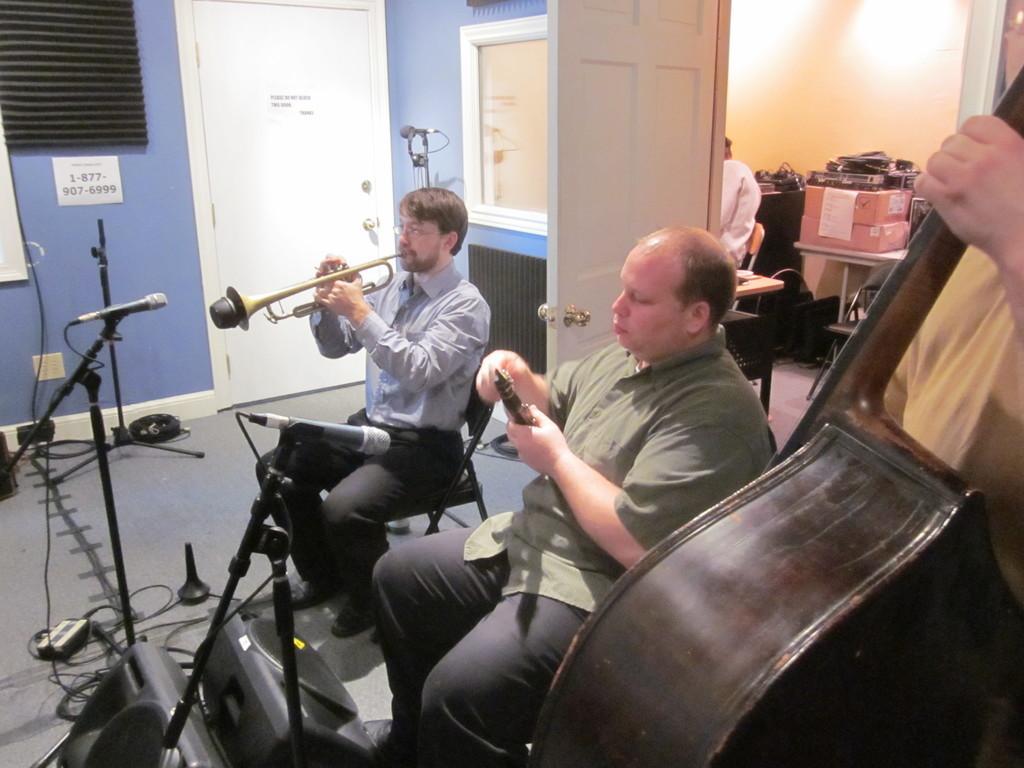Could you give a brief overview of what you see in this image? In this image I can see three persons and I can see all of them are holding musical instruments. In the front of them I can see two mics, wires, two speakers and few things on the floor. In the background I can see two doors, a paper on the wall. one more mic, a stand and on the paper I can see something is written. On the right side of this image I can see few boxes on the table and I can also see few other stuffs near it. 